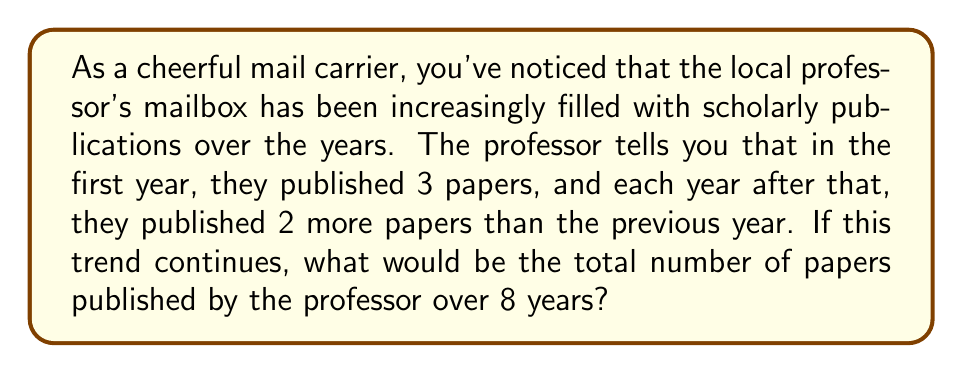Help me with this question. Let's approach this step-by-step using the concept of arithmetic sequences and their partial sums:

1) First, let's identify the arithmetic sequence:
   - First term (a₁) = 3 (papers in the first year)
   - Common difference (d) = 2 (increase each year)

2) The sequence would be: 3, 5, 7, 9, 11, 13, 15, 17

3) We need to find the sum of this arithmetic sequence for 8 terms. The formula for the partial sum of an arithmetic sequence is:

   $$S_n = \frac{n}{2}(a_1 + a_n)$$

   Where:
   $S_n$ is the sum of n terms
   $n$ is the number of terms
   $a_1$ is the first term
   $a_n$ is the last term

4) We know $n = 8$ and $a_1 = 3$. We need to find $a_8$:
   
   $a_n = a_1 + (n-1)d$
   $a_8 = 3 + (8-1)2 = 3 + 14 = 17$

5) Now we can apply the formula:

   $$S_8 = \frac{8}{2}(3 + 17) = 4(20) = 80$$

Therefore, the total number of papers published over 8 years would be 80.
Answer: 80 papers 